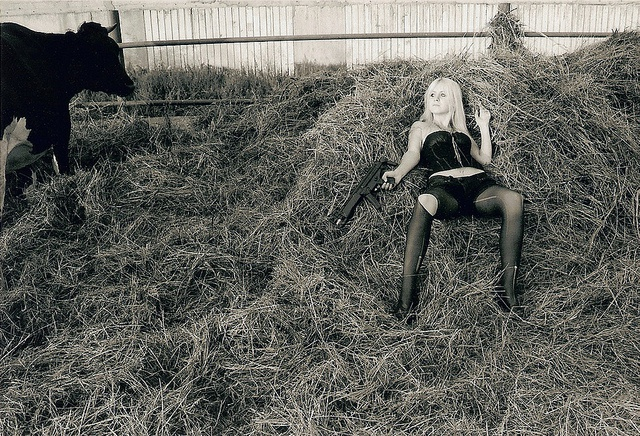Describe the objects in this image and their specific colors. I can see people in lightgray, black, gray, and darkgray tones and cow in lightgray, black, gray, and darkgray tones in this image. 